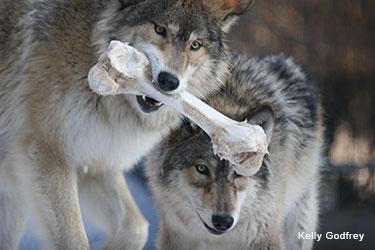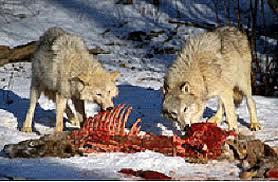The first image is the image on the left, the second image is the image on the right. Given the left and right images, does the statement "Two or more wolves are eating an animal carcass together." hold true? Answer yes or no. Yes. The first image is the image on the left, the second image is the image on the right. For the images displayed, is the sentence "The wild dogs in the image on the right are feeding on their prey." factually correct? Answer yes or no. Yes. 